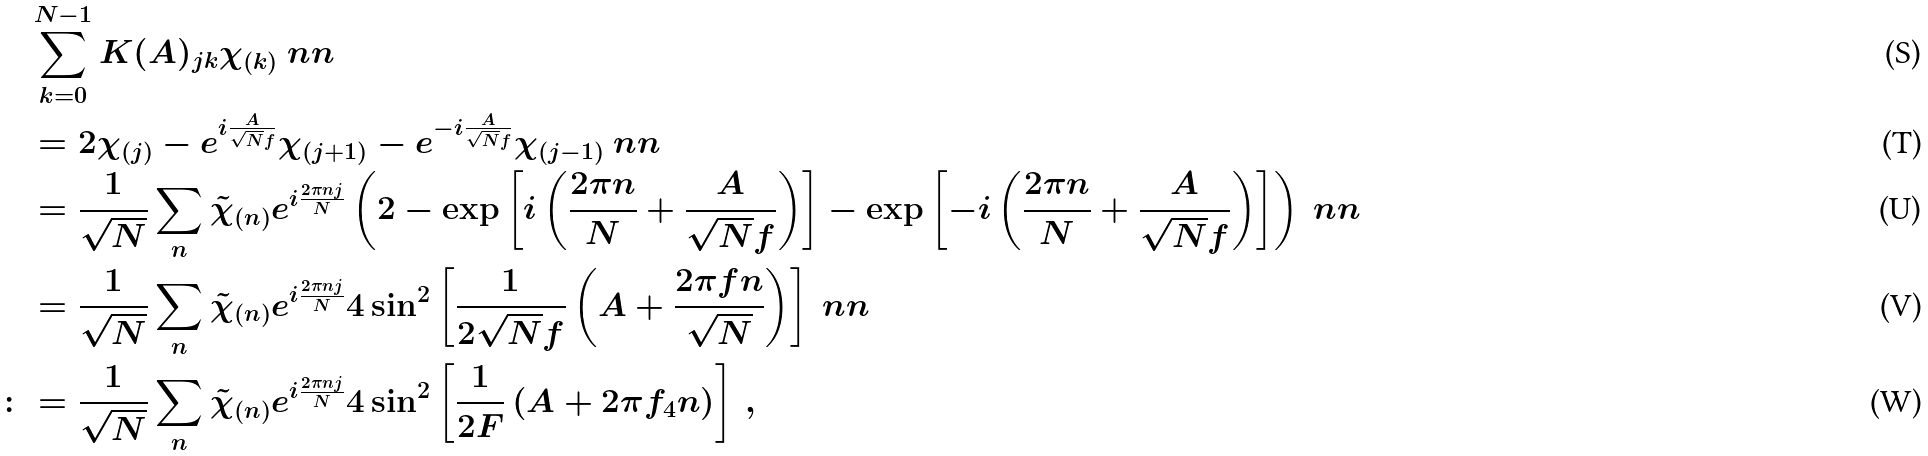<formula> <loc_0><loc_0><loc_500><loc_500>& \sum _ { k = 0 } ^ { N - 1 } K ( A ) _ { j k } \chi _ { ( k ) } \ n n \\ & = 2 { \chi } _ { ( j ) } - e ^ { i \frac { A } { \sqrt { N } f } } { \chi } _ { ( j + 1 ) } - e ^ { - i \frac { A } { \sqrt { N } f } } { \chi } _ { ( j - 1 ) } \ n n \\ & = \frac { 1 } { \sqrt { N } } \sum _ { n } \tilde { \chi } _ { ( n ) } e ^ { i \frac { 2 \pi n j } { N } } \left ( 2 - \exp \left [ i \left ( \frac { 2 \pi n } { N } + \frac { A } { \sqrt { N } f } \right ) \right ] - \exp \left [ - i \left ( \frac { 2 \pi n } { N } + \frac { A } { \sqrt { N } f } \right ) \right ] \right ) \ n n \\ & = \frac { 1 } { \sqrt { N } } \sum _ { n } \tilde { \chi } _ { ( n ) } e ^ { i \frac { 2 \pi n j } { N } } 4 \sin ^ { 2 } \left [ \frac { 1 } { 2 \sqrt { N } f } \left ( A + \frac { 2 \pi f n } { \sqrt { N } } \right ) \right ] \ n n \\ \colon & = \frac { 1 } { \sqrt { N } } \sum _ { n } \tilde { \chi } _ { ( n ) } e ^ { i \frac { 2 \pi n j } { N } } 4 \sin ^ { 2 } \left [ \frac { 1 } { 2 F } \left ( A + { 2 \pi f _ { 4 } n } \right ) \right ] \, ,</formula> 